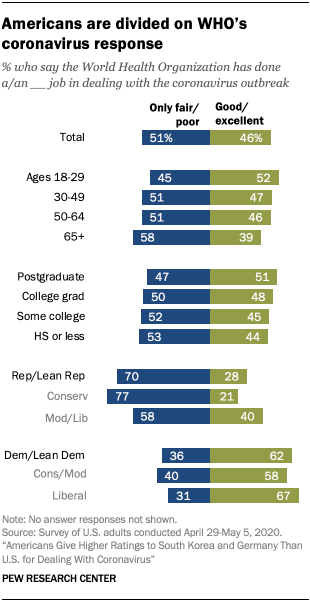Draw attention to some important aspects in this diagram. The value of the first green bar from the bottom is 67. The average score of the blue bar in the 30-49 and 65+ age groups is 54.5. 